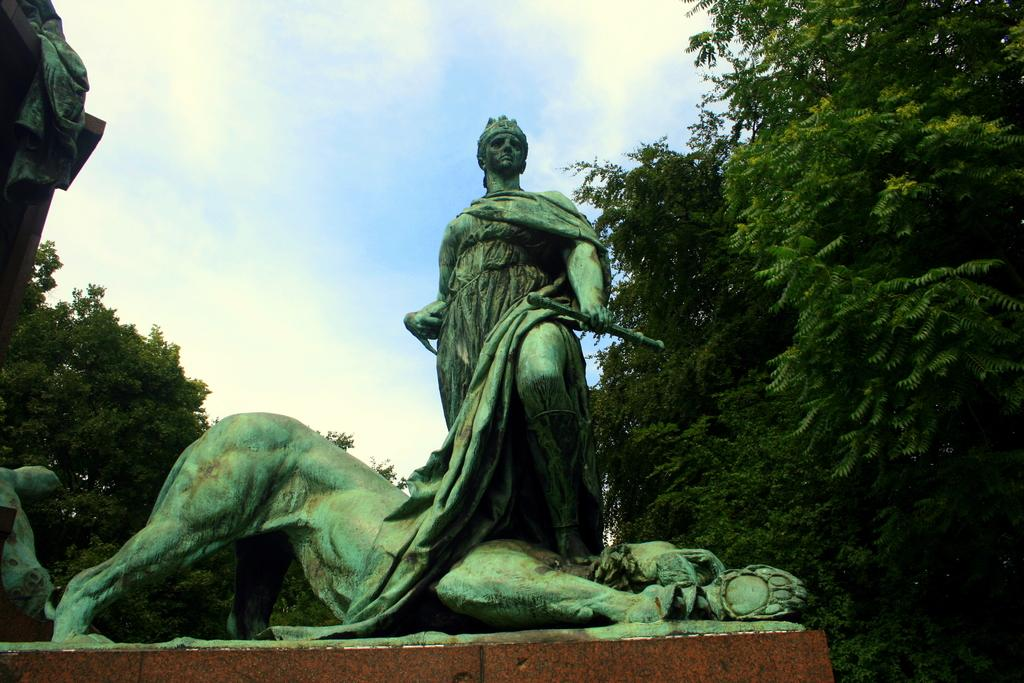What type of objects can be seen in the image? There are statues in the image. What other elements are present in the image besides the statues? There are trees in the image. How would you describe the color of the sky in the image? The sky is blue and white in color. How many rings are visible on the statues in the image? There are no rings present on the statues in the image. What type of hose can be seen watering the trees in the image? There is no hose visible in the image; it only features statues, trees, and the sky. 